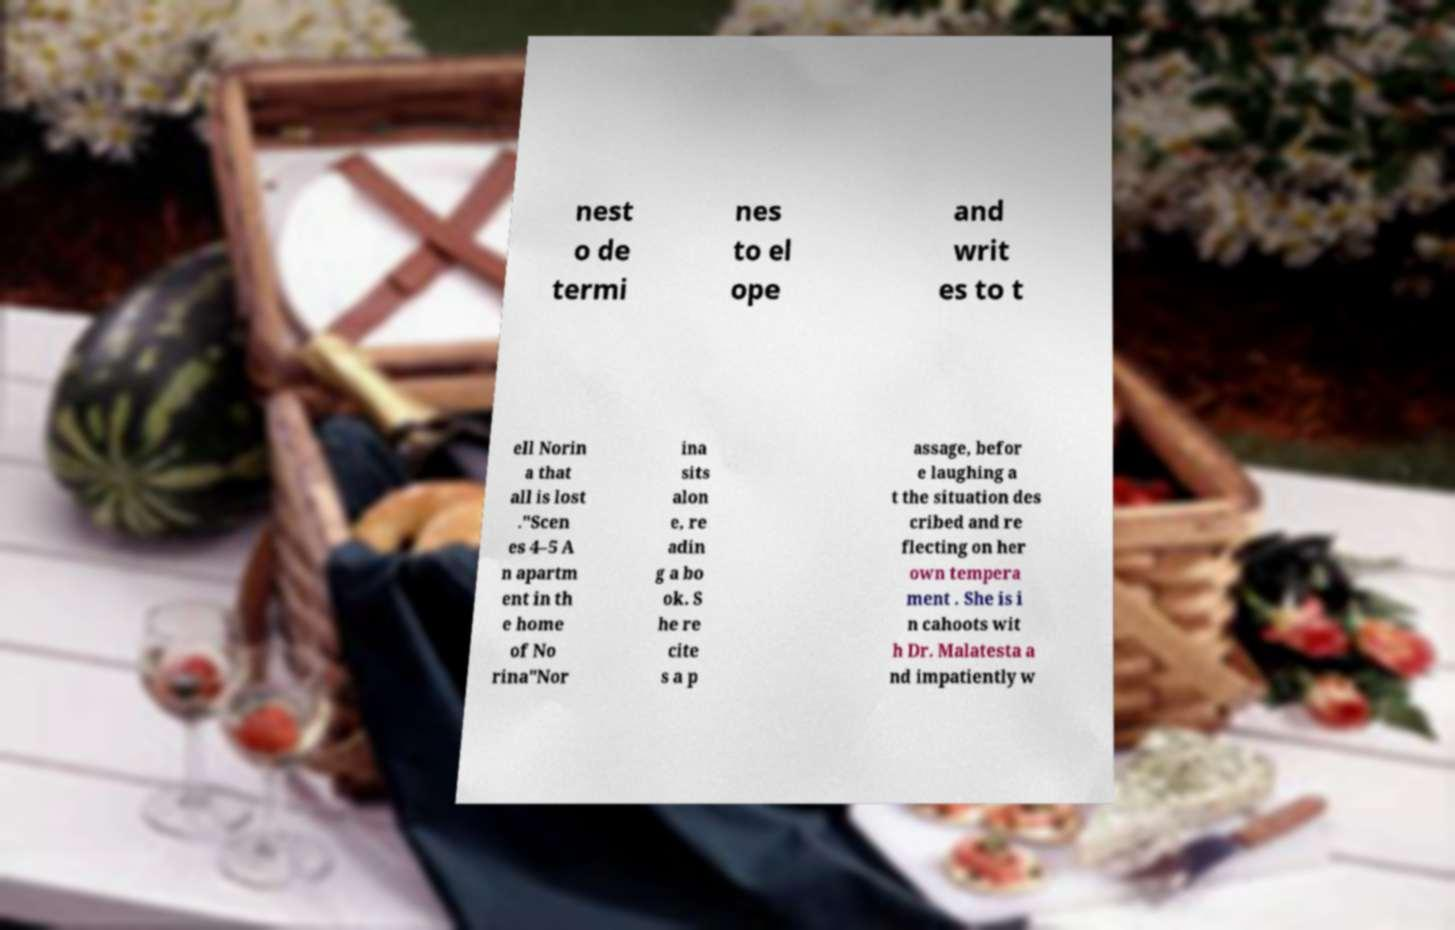For documentation purposes, I need the text within this image transcribed. Could you provide that? nest o de termi nes to el ope and writ es to t ell Norin a that all is lost ."Scen es 4–5 A n apartm ent in th e home of No rina"Nor ina sits alon e, re adin g a bo ok. S he re cite s a p assage, befor e laughing a t the situation des cribed and re flecting on her own tempera ment . She is i n cahoots wit h Dr. Malatesta a nd impatiently w 